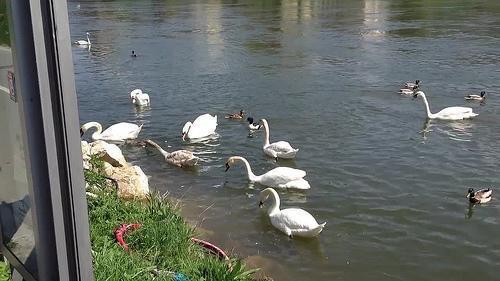How many geese are in the water?
Give a very brief answer. 9. How many ducks are in the water?
Give a very brief answer. 6. 